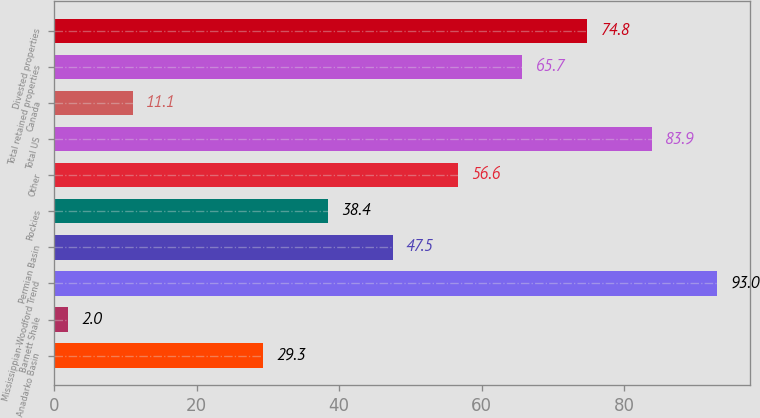Convert chart to OTSL. <chart><loc_0><loc_0><loc_500><loc_500><bar_chart><fcel>Anadarko Basin<fcel>Barnett Shale<fcel>Mississippian-Woodford Trend<fcel>Permian Basin<fcel>Rockies<fcel>Other<fcel>Total US<fcel>Canada<fcel>Total retained properties<fcel>Divested properties<nl><fcel>29.3<fcel>2<fcel>93<fcel>47.5<fcel>38.4<fcel>56.6<fcel>83.9<fcel>11.1<fcel>65.7<fcel>74.8<nl></chart> 